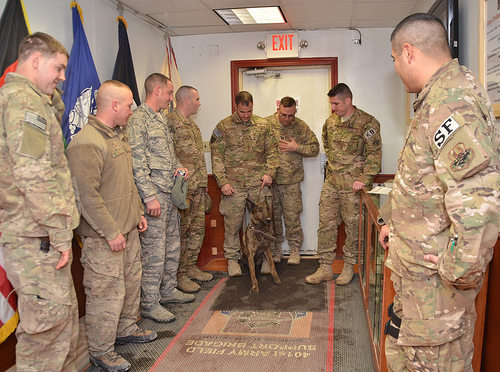<image>
Is the man behind the flag? No. The man is not behind the flag. From this viewpoint, the man appears to be positioned elsewhere in the scene. 